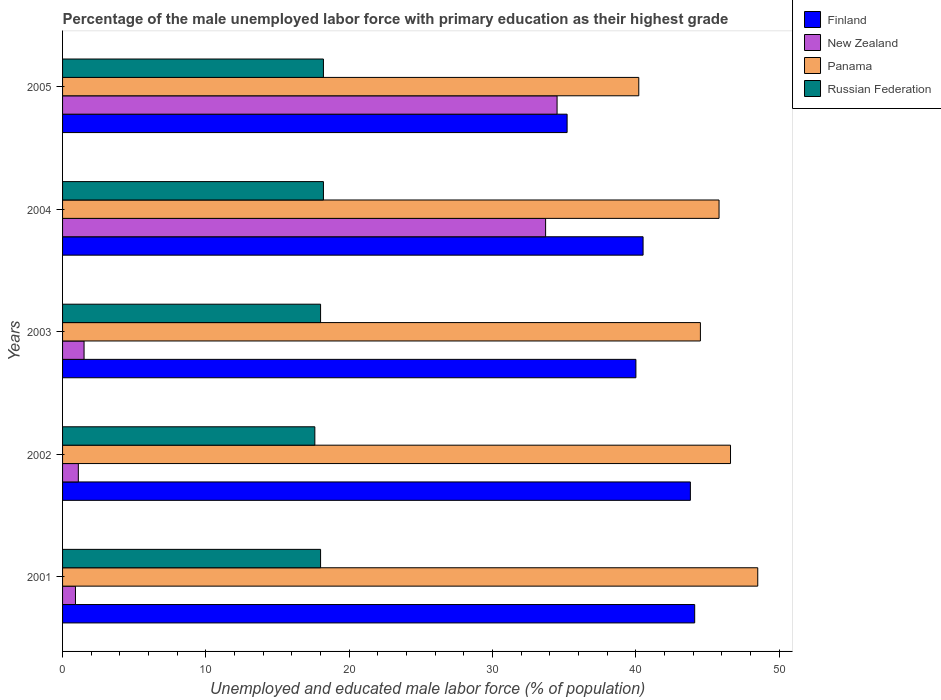How many different coloured bars are there?
Provide a succinct answer. 4. Are the number of bars per tick equal to the number of legend labels?
Offer a very short reply. Yes. How many bars are there on the 4th tick from the top?
Your answer should be very brief. 4. How many bars are there on the 1st tick from the bottom?
Your response must be concise. 4. What is the label of the 2nd group of bars from the top?
Make the answer very short. 2004. What is the percentage of the unemployed male labor force with primary education in Finland in 2004?
Your answer should be very brief. 40.5. Across all years, what is the maximum percentage of the unemployed male labor force with primary education in Panama?
Provide a short and direct response. 48.5. Across all years, what is the minimum percentage of the unemployed male labor force with primary education in New Zealand?
Ensure brevity in your answer.  0.9. In which year was the percentage of the unemployed male labor force with primary education in New Zealand maximum?
Offer a terse response. 2005. In which year was the percentage of the unemployed male labor force with primary education in New Zealand minimum?
Offer a terse response. 2001. What is the total percentage of the unemployed male labor force with primary education in Panama in the graph?
Your answer should be very brief. 225.6. What is the difference between the percentage of the unemployed male labor force with primary education in New Zealand in 2001 and that in 2005?
Ensure brevity in your answer.  -33.6. What is the average percentage of the unemployed male labor force with primary education in Russian Federation per year?
Give a very brief answer. 18. In how many years, is the percentage of the unemployed male labor force with primary education in Finland greater than 42 %?
Keep it short and to the point. 2. What is the ratio of the percentage of the unemployed male labor force with primary education in Panama in 2004 to that in 2005?
Give a very brief answer. 1.14. Is the percentage of the unemployed male labor force with primary education in New Zealand in 2003 less than that in 2005?
Offer a very short reply. Yes. What is the difference between the highest and the second highest percentage of the unemployed male labor force with primary education in Finland?
Offer a terse response. 0.3. What is the difference between the highest and the lowest percentage of the unemployed male labor force with primary education in Panama?
Offer a very short reply. 8.3. In how many years, is the percentage of the unemployed male labor force with primary education in Finland greater than the average percentage of the unemployed male labor force with primary education in Finland taken over all years?
Provide a short and direct response. 2. What does the 1st bar from the top in 2003 represents?
Your answer should be compact. Russian Federation. What does the 2nd bar from the bottom in 2005 represents?
Provide a short and direct response. New Zealand. Are all the bars in the graph horizontal?
Provide a succinct answer. Yes. Are the values on the major ticks of X-axis written in scientific E-notation?
Your answer should be very brief. No. How are the legend labels stacked?
Your answer should be compact. Vertical. What is the title of the graph?
Your response must be concise. Percentage of the male unemployed labor force with primary education as their highest grade. Does "Turkey" appear as one of the legend labels in the graph?
Offer a very short reply. No. What is the label or title of the X-axis?
Offer a terse response. Unemployed and educated male labor force (% of population). What is the label or title of the Y-axis?
Make the answer very short. Years. What is the Unemployed and educated male labor force (% of population) of Finland in 2001?
Give a very brief answer. 44.1. What is the Unemployed and educated male labor force (% of population) of New Zealand in 2001?
Provide a succinct answer. 0.9. What is the Unemployed and educated male labor force (% of population) in Panama in 2001?
Offer a very short reply. 48.5. What is the Unemployed and educated male labor force (% of population) in Russian Federation in 2001?
Provide a succinct answer. 18. What is the Unemployed and educated male labor force (% of population) in Finland in 2002?
Offer a terse response. 43.8. What is the Unemployed and educated male labor force (% of population) of New Zealand in 2002?
Keep it short and to the point. 1.1. What is the Unemployed and educated male labor force (% of population) in Panama in 2002?
Your response must be concise. 46.6. What is the Unemployed and educated male labor force (% of population) in Russian Federation in 2002?
Your answer should be very brief. 17.6. What is the Unemployed and educated male labor force (% of population) of Panama in 2003?
Offer a terse response. 44.5. What is the Unemployed and educated male labor force (% of population) in Finland in 2004?
Offer a very short reply. 40.5. What is the Unemployed and educated male labor force (% of population) in New Zealand in 2004?
Keep it short and to the point. 33.7. What is the Unemployed and educated male labor force (% of population) of Panama in 2004?
Your answer should be very brief. 45.8. What is the Unemployed and educated male labor force (% of population) in Russian Federation in 2004?
Offer a very short reply. 18.2. What is the Unemployed and educated male labor force (% of population) of Finland in 2005?
Make the answer very short. 35.2. What is the Unemployed and educated male labor force (% of population) of New Zealand in 2005?
Keep it short and to the point. 34.5. What is the Unemployed and educated male labor force (% of population) of Panama in 2005?
Your answer should be compact. 40.2. What is the Unemployed and educated male labor force (% of population) in Russian Federation in 2005?
Make the answer very short. 18.2. Across all years, what is the maximum Unemployed and educated male labor force (% of population) of Finland?
Your response must be concise. 44.1. Across all years, what is the maximum Unemployed and educated male labor force (% of population) of New Zealand?
Your answer should be compact. 34.5. Across all years, what is the maximum Unemployed and educated male labor force (% of population) of Panama?
Give a very brief answer. 48.5. Across all years, what is the maximum Unemployed and educated male labor force (% of population) in Russian Federation?
Your answer should be very brief. 18.2. Across all years, what is the minimum Unemployed and educated male labor force (% of population) of Finland?
Make the answer very short. 35.2. Across all years, what is the minimum Unemployed and educated male labor force (% of population) in New Zealand?
Provide a succinct answer. 0.9. Across all years, what is the minimum Unemployed and educated male labor force (% of population) of Panama?
Provide a succinct answer. 40.2. Across all years, what is the minimum Unemployed and educated male labor force (% of population) in Russian Federation?
Your answer should be very brief. 17.6. What is the total Unemployed and educated male labor force (% of population) of Finland in the graph?
Keep it short and to the point. 203.6. What is the total Unemployed and educated male labor force (% of population) in New Zealand in the graph?
Ensure brevity in your answer.  71.7. What is the total Unemployed and educated male labor force (% of population) of Panama in the graph?
Offer a terse response. 225.6. What is the difference between the Unemployed and educated male labor force (% of population) of Finland in 2001 and that in 2002?
Give a very brief answer. 0.3. What is the difference between the Unemployed and educated male labor force (% of population) of New Zealand in 2001 and that in 2002?
Your answer should be compact. -0.2. What is the difference between the Unemployed and educated male labor force (% of population) in Russian Federation in 2001 and that in 2002?
Provide a short and direct response. 0.4. What is the difference between the Unemployed and educated male labor force (% of population) of Finland in 2001 and that in 2003?
Ensure brevity in your answer.  4.1. What is the difference between the Unemployed and educated male labor force (% of population) of New Zealand in 2001 and that in 2003?
Your response must be concise. -0.6. What is the difference between the Unemployed and educated male labor force (% of population) of Panama in 2001 and that in 2003?
Keep it short and to the point. 4. What is the difference between the Unemployed and educated male labor force (% of population) of Russian Federation in 2001 and that in 2003?
Your answer should be very brief. 0. What is the difference between the Unemployed and educated male labor force (% of population) in New Zealand in 2001 and that in 2004?
Your response must be concise. -32.8. What is the difference between the Unemployed and educated male labor force (% of population) in Panama in 2001 and that in 2004?
Make the answer very short. 2.7. What is the difference between the Unemployed and educated male labor force (% of population) in New Zealand in 2001 and that in 2005?
Your answer should be compact. -33.6. What is the difference between the Unemployed and educated male labor force (% of population) in Russian Federation in 2001 and that in 2005?
Make the answer very short. -0.2. What is the difference between the Unemployed and educated male labor force (% of population) of New Zealand in 2002 and that in 2003?
Your answer should be compact. -0.4. What is the difference between the Unemployed and educated male labor force (% of population) in Panama in 2002 and that in 2003?
Provide a succinct answer. 2.1. What is the difference between the Unemployed and educated male labor force (% of population) in New Zealand in 2002 and that in 2004?
Offer a terse response. -32.6. What is the difference between the Unemployed and educated male labor force (% of population) in Russian Federation in 2002 and that in 2004?
Offer a very short reply. -0.6. What is the difference between the Unemployed and educated male labor force (% of population) of Finland in 2002 and that in 2005?
Ensure brevity in your answer.  8.6. What is the difference between the Unemployed and educated male labor force (% of population) of New Zealand in 2002 and that in 2005?
Ensure brevity in your answer.  -33.4. What is the difference between the Unemployed and educated male labor force (% of population) of Russian Federation in 2002 and that in 2005?
Offer a very short reply. -0.6. What is the difference between the Unemployed and educated male labor force (% of population) in Finland in 2003 and that in 2004?
Your answer should be very brief. -0.5. What is the difference between the Unemployed and educated male labor force (% of population) of New Zealand in 2003 and that in 2004?
Your response must be concise. -32.2. What is the difference between the Unemployed and educated male labor force (% of population) of Panama in 2003 and that in 2004?
Your answer should be compact. -1.3. What is the difference between the Unemployed and educated male labor force (% of population) in New Zealand in 2003 and that in 2005?
Offer a very short reply. -33. What is the difference between the Unemployed and educated male labor force (% of population) in Panama in 2003 and that in 2005?
Your response must be concise. 4.3. What is the difference between the Unemployed and educated male labor force (% of population) of Finland in 2004 and that in 2005?
Offer a very short reply. 5.3. What is the difference between the Unemployed and educated male labor force (% of population) in New Zealand in 2004 and that in 2005?
Provide a succinct answer. -0.8. What is the difference between the Unemployed and educated male labor force (% of population) of Finland in 2001 and the Unemployed and educated male labor force (% of population) of Panama in 2002?
Ensure brevity in your answer.  -2.5. What is the difference between the Unemployed and educated male labor force (% of population) in New Zealand in 2001 and the Unemployed and educated male labor force (% of population) in Panama in 2002?
Offer a very short reply. -45.7. What is the difference between the Unemployed and educated male labor force (% of population) of New Zealand in 2001 and the Unemployed and educated male labor force (% of population) of Russian Federation in 2002?
Keep it short and to the point. -16.7. What is the difference between the Unemployed and educated male labor force (% of population) in Panama in 2001 and the Unemployed and educated male labor force (% of population) in Russian Federation in 2002?
Offer a very short reply. 30.9. What is the difference between the Unemployed and educated male labor force (% of population) in Finland in 2001 and the Unemployed and educated male labor force (% of population) in New Zealand in 2003?
Make the answer very short. 42.6. What is the difference between the Unemployed and educated male labor force (% of population) in Finland in 2001 and the Unemployed and educated male labor force (% of population) in Russian Federation in 2003?
Your response must be concise. 26.1. What is the difference between the Unemployed and educated male labor force (% of population) of New Zealand in 2001 and the Unemployed and educated male labor force (% of population) of Panama in 2003?
Make the answer very short. -43.6. What is the difference between the Unemployed and educated male labor force (% of population) in New Zealand in 2001 and the Unemployed and educated male labor force (% of population) in Russian Federation in 2003?
Make the answer very short. -17.1. What is the difference between the Unemployed and educated male labor force (% of population) of Panama in 2001 and the Unemployed and educated male labor force (% of population) of Russian Federation in 2003?
Your response must be concise. 30.5. What is the difference between the Unemployed and educated male labor force (% of population) in Finland in 2001 and the Unemployed and educated male labor force (% of population) in Russian Federation in 2004?
Give a very brief answer. 25.9. What is the difference between the Unemployed and educated male labor force (% of population) in New Zealand in 2001 and the Unemployed and educated male labor force (% of population) in Panama in 2004?
Your response must be concise. -44.9. What is the difference between the Unemployed and educated male labor force (% of population) of New Zealand in 2001 and the Unemployed and educated male labor force (% of population) of Russian Federation in 2004?
Offer a very short reply. -17.3. What is the difference between the Unemployed and educated male labor force (% of population) of Panama in 2001 and the Unemployed and educated male labor force (% of population) of Russian Federation in 2004?
Make the answer very short. 30.3. What is the difference between the Unemployed and educated male labor force (% of population) in Finland in 2001 and the Unemployed and educated male labor force (% of population) in New Zealand in 2005?
Make the answer very short. 9.6. What is the difference between the Unemployed and educated male labor force (% of population) of Finland in 2001 and the Unemployed and educated male labor force (% of population) of Panama in 2005?
Give a very brief answer. 3.9. What is the difference between the Unemployed and educated male labor force (% of population) in Finland in 2001 and the Unemployed and educated male labor force (% of population) in Russian Federation in 2005?
Your answer should be compact. 25.9. What is the difference between the Unemployed and educated male labor force (% of population) of New Zealand in 2001 and the Unemployed and educated male labor force (% of population) of Panama in 2005?
Provide a succinct answer. -39.3. What is the difference between the Unemployed and educated male labor force (% of population) in New Zealand in 2001 and the Unemployed and educated male labor force (% of population) in Russian Federation in 2005?
Your answer should be very brief. -17.3. What is the difference between the Unemployed and educated male labor force (% of population) of Panama in 2001 and the Unemployed and educated male labor force (% of population) of Russian Federation in 2005?
Keep it short and to the point. 30.3. What is the difference between the Unemployed and educated male labor force (% of population) of Finland in 2002 and the Unemployed and educated male labor force (% of population) of New Zealand in 2003?
Give a very brief answer. 42.3. What is the difference between the Unemployed and educated male labor force (% of population) in Finland in 2002 and the Unemployed and educated male labor force (% of population) in Russian Federation in 2003?
Provide a short and direct response. 25.8. What is the difference between the Unemployed and educated male labor force (% of population) of New Zealand in 2002 and the Unemployed and educated male labor force (% of population) of Panama in 2003?
Your answer should be very brief. -43.4. What is the difference between the Unemployed and educated male labor force (% of population) of New Zealand in 2002 and the Unemployed and educated male labor force (% of population) of Russian Federation in 2003?
Provide a succinct answer. -16.9. What is the difference between the Unemployed and educated male labor force (% of population) in Panama in 2002 and the Unemployed and educated male labor force (% of population) in Russian Federation in 2003?
Your response must be concise. 28.6. What is the difference between the Unemployed and educated male labor force (% of population) of Finland in 2002 and the Unemployed and educated male labor force (% of population) of New Zealand in 2004?
Keep it short and to the point. 10.1. What is the difference between the Unemployed and educated male labor force (% of population) in Finland in 2002 and the Unemployed and educated male labor force (% of population) in Russian Federation in 2004?
Offer a terse response. 25.6. What is the difference between the Unemployed and educated male labor force (% of population) in New Zealand in 2002 and the Unemployed and educated male labor force (% of population) in Panama in 2004?
Give a very brief answer. -44.7. What is the difference between the Unemployed and educated male labor force (% of population) in New Zealand in 2002 and the Unemployed and educated male labor force (% of population) in Russian Federation in 2004?
Offer a terse response. -17.1. What is the difference between the Unemployed and educated male labor force (% of population) of Panama in 2002 and the Unemployed and educated male labor force (% of population) of Russian Federation in 2004?
Offer a terse response. 28.4. What is the difference between the Unemployed and educated male labor force (% of population) in Finland in 2002 and the Unemployed and educated male labor force (% of population) in New Zealand in 2005?
Provide a succinct answer. 9.3. What is the difference between the Unemployed and educated male labor force (% of population) of Finland in 2002 and the Unemployed and educated male labor force (% of population) of Russian Federation in 2005?
Offer a terse response. 25.6. What is the difference between the Unemployed and educated male labor force (% of population) in New Zealand in 2002 and the Unemployed and educated male labor force (% of population) in Panama in 2005?
Provide a succinct answer. -39.1. What is the difference between the Unemployed and educated male labor force (% of population) in New Zealand in 2002 and the Unemployed and educated male labor force (% of population) in Russian Federation in 2005?
Your answer should be very brief. -17.1. What is the difference between the Unemployed and educated male labor force (% of population) of Panama in 2002 and the Unemployed and educated male labor force (% of population) of Russian Federation in 2005?
Offer a very short reply. 28.4. What is the difference between the Unemployed and educated male labor force (% of population) of Finland in 2003 and the Unemployed and educated male labor force (% of population) of New Zealand in 2004?
Ensure brevity in your answer.  6.3. What is the difference between the Unemployed and educated male labor force (% of population) of Finland in 2003 and the Unemployed and educated male labor force (% of population) of Panama in 2004?
Make the answer very short. -5.8. What is the difference between the Unemployed and educated male labor force (% of population) in Finland in 2003 and the Unemployed and educated male labor force (% of population) in Russian Federation in 2004?
Your answer should be very brief. 21.8. What is the difference between the Unemployed and educated male labor force (% of population) of New Zealand in 2003 and the Unemployed and educated male labor force (% of population) of Panama in 2004?
Make the answer very short. -44.3. What is the difference between the Unemployed and educated male labor force (% of population) of New Zealand in 2003 and the Unemployed and educated male labor force (% of population) of Russian Federation in 2004?
Your answer should be very brief. -16.7. What is the difference between the Unemployed and educated male labor force (% of population) of Panama in 2003 and the Unemployed and educated male labor force (% of population) of Russian Federation in 2004?
Your response must be concise. 26.3. What is the difference between the Unemployed and educated male labor force (% of population) of Finland in 2003 and the Unemployed and educated male labor force (% of population) of New Zealand in 2005?
Provide a succinct answer. 5.5. What is the difference between the Unemployed and educated male labor force (% of population) in Finland in 2003 and the Unemployed and educated male labor force (% of population) in Panama in 2005?
Your response must be concise. -0.2. What is the difference between the Unemployed and educated male labor force (% of population) in Finland in 2003 and the Unemployed and educated male labor force (% of population) in Russian Federation in 2005?
Provide a succinct answer. 21.8. What is the difference between the Unemployed and educated male labor force (% of population) of New Zealand in 2003 and the Unemployed and educated male labor force (% of population) of Panama in 2005?
Provide a short and direct response. -38.7. What is the difference between the Unemployed and educated male labor force (% of population) in New Zealand in 2003 and the Unemployed and educated male labor force (% of population) in Russian Federation in 2005?
Give a very brief answer. -16.7. What is the difference between the Unemployed and educated male labor force (% of population) in Panama in 2003 and the Unemployed and educated male labor force (% of population) in Russian Federation in 2005?
Provide a short and direct response. 26.3. What is the difference between the Unemployed and educated male labor force (% of population) in Finland in 2004 and the Unemployed and educated male labor force (% of population) in Russian Federation in 2005?
Offer a terse response. 22.3. What is the difference between the Unemployed and educated male labor force (% of population) in New Zealand in 2004 and the Unemployed and educated male labor force (% of population) in Panama in 2005?
Give a very brief answer. -6.5. What is the difference between the Unemployed and educated male labor force (% of population) in New Zealand in 2004 and the Unemployed and educated male labor force (% of population) in Russian Federation in 2005?
Offer a very short reply. 15.5. What is the difference between the Unemployed and educated male labor force (% of population) of Panama in 2004 and the Unemployed and educated male labor force (% of population) of Russian Federation in 2005?
Your answer should be compact. 27.6. What is the average Unemployed and educated male labor force (% of population) in Finland per year?
Offer a terse response. 40.72. What is the average Unemployed and educated male labor force (% of population) in New Zealand per year?
Your answer should be very brief. 14.34. What is the average Unemployed and educated male labor force (% of population) of Panama per year?
Offer a terse response. 45.12. What is the average Unemployed and educated male labor force (% of population) in Russian Federation per year?
Your response must be concise. 18. In the year 2001, what is the difference between the Unemployed and educated male labor force (% of population) of Finland and Unemployed and educated male labor force (% of population) of New Zealand?
Provide a succinct answer. 43.2. In the year 2001, what is the difference between the Unemployed and educated male labor force (% of population) in Finland and Unemployed and educated male labor force (% of population) in Panama?
Provide a succinct answer. -4.4. In the year 2001, what is the difference between the Unemployed and educated male labor force (% of population) of Finland and Unemployed and educated male labor force (% of population) of Russian Federation?
Your answer should be very brief. 26.1. In the year 2001, what is the difference between the Unemployed and educated male labor force (% of population) in New Zealand and Unemployed and educated male labor force (% of population) in Panama?
Offer a terse response. -47.6. In the year 2001, what is the difference between the Unemployed and educated male labor force (% of population) of New Zealand and Unemployed and educated male labor force (% of population) of Russian Federation?
Give a very brief answer. -17.1. In the year 2001, what is the difference between the Unemployed and educated male labor force (% of population) in Panama and Unemployed and educated male labor force (% of population) in Russian Federation?
Provide a succinct answer. 30.5. In the year 2002, what is the difference between the Unemployed and educated male labor force (% of population) of Finland and Unemployed and educated male labor force (% of population) of New Zealand?
Ensure brevity in your answer.  42.7. In the year 2002, what is the difference between the Unemployed and educated male labor force (% of population) in Finland and Unemployed and educated male labor force (% of population) in Russian Federation?
Your answer should be very brief. 26.2. In the year 2002, what is the difference between the Unemployed and educated male labor force (% of population) of New Zealand and Unemployed and educated male labor force (% of population) of Panama?
Your answer should be very brief. -45.5. In the year 2002, what is the difference between the Unemployed and educated male labor force (% of population) of New Zealand and Unemployed and educated male labor force (% of population) of Russian Federation?
Offer a very short reply. -16.5. In the year 2002, what is the difference between the Unemployed and educated male labor force (% of population) of Panama and Unemployed and educated male labor force (% of population) of Russian Federation?
Your response must be concise. 29. In the year 2003, what is the difference between the Unemployed and educated male labor force (% of population) in Finland and Unemployed and educated male labor force (% of population) in New Zealand?
Ensure brevity in your answer.  38.5. In the year 2003, what is the difference between the Unemployed and educated male labor force (% of population) in Finland and Unemployed and educated male labor force (% of population) in Panama?
Your response must be concise. -4.5. In the year 2003, what is the difference between the Unemployed and educated male labor force (% of population) in New Zealand and Unemployed and educated male labor force (% of population) in Panama?
Offer a terse response. -43. In the year 2003, what is the difference between the Unemployed and educated male labor force (% of population) in New Zealand and Unemployed and educated male labor force (% of population) in Russian Federation?
Keep it short and to the point. -16.5. In the year 2003, what is the difference between the Unemployed and educated male labor force (% of population) in Panama and Unemployed and educated male labor force (% of population) in Russian Federation?
Make the answer very short. 26.5. In the year 2004, what is the difference between the Unemployed and educated male labor force (% of population) of Finland and Unemployed and educated male labor force (% of population) of New Zealand?
Offer a terse response. 6.8. In the year 2004, what is the difference between the Unemployed and educated male labor force (% of population) in Finland and Unemployed and educated male labor force (% of population) in Panama?
Make the answer very short. -5.3. In the year 2004, what is the difference between the Unemployed and educated male labor force (% of population) in Finland and Unemployed and educated male labor force (% of population) in Russian Federation?
Ensure brevity in your answer.  22.3. In the year 2004, what is the difference between the Unemployed and educated male labor force (% of population) in New Zealand and Unemployed and educated male labor force (% of population) in Panama?
Offer a very short reply. -12.1. In the year 2004, what is the difference between the Unemployed and educated male labor force (% of population) in New Zealand and Unemployed and educated male labor force (% of population) in Russian Federation?
Ensure brevity in your answer.  15.5. In the year 2004, what is the difference between the Unemployed and educated male labor force (% of population) of Panama and Unemployed and educated male labor force (% of population) of Russian Federation?
Ensure brevity in your answer.  27.6. In the year 2005, what is the difference between the Unemployed and educated male labor force (% of population) in Finland and Unemployed and educated male labor force (% of population) in New Zealand?
Give a very brief answer. 0.7. In the year 2005, what is the difference between the Unemployed and educated male labor force (% of population) in Finland and Unemployed and educated male labor force (% of population) in Panama?
Give a very brief answer. -5. In the year 2005, what is the difference between the Unemployed and educated male labor force (% of population) of Finland and Unemployed and educated male labor force (% of population) of Russian Federation?
Ensure brevity in your answer.  17. In the year 2005, what is the difference between the Unemployed and educated male labor force (% of population) in New Zealand and Unemployed and educated male labor force (% of population) in Panama?
Provide a short and direct response. -5.7. In the year 2005, what is the difference between the Unemployed and educated male labor force (% of population) in New Zealand and Unemployed and educated male labor force (% of population) in Russian Federation?
Provide a succinct answer. 16.3. What is the ratio of the Unemployed and educated male labor force (% of population) in Finland in 2001 to that in 2002?
Make the answer very short. 1.01. What is the ratio of the Unemployed and educated male labor force (% of population) of New Zealand in 2001 to that in 2002?
Your response must be concise. 0.82. What is the ratio of the Unemployed and educated male labor force (% of population) in Panama in 2001 to that in 2002?
Provide a succinct answer. 1.04. What is the ratio of the Unemployed and educated male labor force (% of population) in Russian Federation in 2001 to that in 2002?
Provide a short and direct response. 1.02. What is the ratio of the Unemployed and educated male labor force (% of population) of Finland in 2001 to that in 2003?
Make the answer very short. 1.1. What is the ratio of the Unemployed and educated male labor force (% of population) of New Zealand in 2001 to that in 2003?
Your response must be concise. 0.6. What is the ratio of the Unemployed and educated male labor force (% of population) of Panama in 2001 to that in 2003?
Ensure brevity in your answer.  1.09. What is the ratio of the Unemployed and educated male labor force (% of population) of Finland in 2001 to that in 2004?
Provide a short and direct response. 1.09. What is the ratio of the Unemployed and educated male labor force (% of population) in New Zealand in 2001 to that in 2004?
Provide a succinct answer. 0.03. What is the ratio of the Unemployed and educated male labor force (% of population) of Panama in 2001 to that in 2004?
Your response must be concise. 1.06. What is the ratio of the Unemployed and educated male labor force (% of population) in Finland in 2001 to that in 2005?
Make the answer very short. 1.25. What is the ratio of the Unemployed and educated male labor force (% of population) in New Zealand in 2001 to that in 2005?
Provide a succinct answer. 0.03. What is the ratio of the Unemployed and educated male labor force (% of population) in Panama in 2001 to that in 2005?
Ensure brevity in your answer.  1.21. What is the ratio of the Unemployed and educated male labor force (% of population) of Russian Federation in 2001 to that in 2005?
Your answer should be very brief. 0.99. What is the ratio of the Unemployed and educated male labor force (% of population) in Finland in 2002 to that in 2003?
Offer a very short reply. 1.09. What is the ratio of the Unemployed and educated male labor force (% of population) of New Zealand in 2002 to that in 2003?
Your response must be concise. 0.73. What is the ratio of the Unemployed and educated male labor force (% of population) of Panama in 2002 to that in 2003?
Offer a terse response. 1.05. What is the ratio of the Unemployed and educated male labor force (% of population) of Russian Federation in 2002 to that in 2003?
Give a very brief answer. 0.98. What is the ratio of the Unemployed and educated male labor force (% of population) in Finland in 2002 to that in 2004?
Ensure brevity in your answer.  1.08. What is the ratio of the Unemployed and educated male labor force (% of population) in New Zealand in 2002 to that in 2004?
Your answer should be very brief. 0.03. What is the ratio of the Unemployed and educated male labor force (% of population) in Panama in 2002 to that in 2004?
Provide a short and direct response. 1.02. What is the ratio of the Unemployed and educated male labor force (% of population) in Russian Federation in 2002 to that in 2004?
Your answer should be very brief. 0.97. What is the ratio of the Unemployed and educated male labor force (% of population) of Finland in 2002 to that in 2005?
Give a very brief answer. 1.24. What is the ratio of the Unemployed and educated male labor force (% of population) of New Zealand in 2002 to that in 2005?
Provide a short and direct response. 0.03. What is the ratio of the Unemployed and educated male labor force (% of population) in Panama in 2002 to that in 2005?
Offer a terse response. 1.16. What is the ratio of the Unemployed and educated male labor force (% of population) of Russian Federation in 2002 to that in 2005?
Provide a short and direct response. 0.97. What is the ratio of the Unemployed and educated male labor force (% of population) of Finland in 2003 to that in 2004?
Provide a short and direct response. 0.99. What is the ratio of the Unemployed and educated male labor force (% of population) of New Zealand in 2003 to that in 2004?
Your response must be concise. 0.04. What is the ratio of the Unemployed and educated male labor force (% of population) of Panama in 2003 to that in 2004?
Ensure brevity in your answer.  0.97. What is the ratio of the Unemployed and educated male labor force (% of population) of Russian Federation in 2003 to that in 2004?
Your answer should be compact. 0.99. What is the ratio of the Unemployed and educated male labor force (% of population) in Finland in 2003 to that in 2005?
Keep it short and to the point. 1.14. What is the ratio of the Unemployed and educated male labor force (% of population) in New Zealand in 2003 to that in 2005?
Your response must be concise. 0.04. What is the ratio of the Unemployed and educated male labor force (% of population) in Panama in 2003 to that in 2005?
Your response must be concise. 1.11. What is the ratio of the Unemployed and educated male labor force (% of population) in Russian Federation in 2003 to that in 2005?
Offer a very short reply. 0.99. What is the ratio of the Unemployed and educated male labor force (% of population) in Finland in 2004 to that in 2005?
Give a very brief answer. 1.15. What is the ratio of the Unemployed and educated male labor force (% of population) of New Zealand in 2004 to that in 2005?
Offer a very short reply. 0.98. What is the ratio of the Unemployed and educated male labor force (% of population) in Panama in 2004 to that in 2005?
Your answer should be very brief. 1.14. What is the ratio of the Unemployed and educated male labor force (% of population) in Russian Federation in 2004 to that in 2005?
Provide a short and direct response. 1. What is the difference between the highest and the second highest Unemployed and educated male labor force (% of population) in Finland?
Your answer should be compact. 0.3. What is the difference between the highest and the second highest Unemployed and educated male labor force (% of population) in New Zealand?
Your response must be concise. 0.8. What is the difference between the highest and the second highest Unemployed and educated male labor force (% of population) in Russian Federation?
Make the answer very short. 0. What is the difference between the highest and the lowest Unemployed and educated male labor force (% of population) in Finland?
Provide a succinct answer. 8.9. What is the difference between the highest and the lowest Unemployed and educated male labor force (% of population) in New Zealand?
Keep it short and to the point. 33.6. What is the difference between the highest and the lowest Unemployed and educated male labor force (% of population) in Panama?
Make the answer very short. 8.3. 